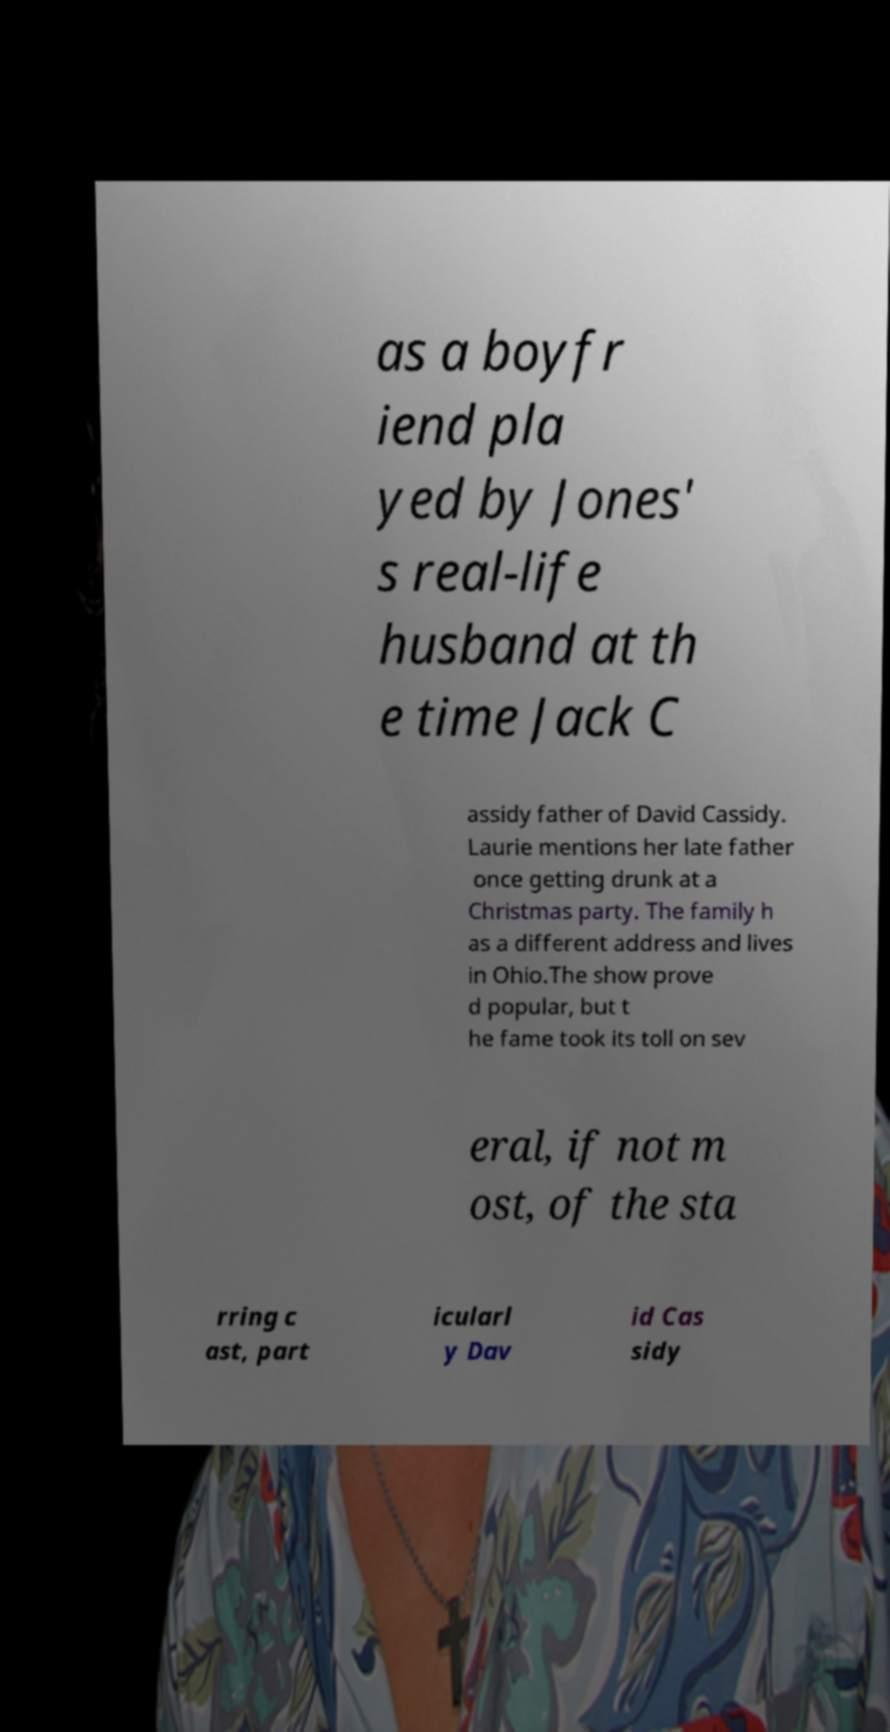For documentation purposes, I need the text within this image transcribed. Could you provide that? as a boyfr iend pla yed by Jones' s real-life husband at th e time Jack C assidy father of David Cassidy. Laurie mentions her late father once getting drunk at a Christmas party. The family h as a different address and lives in Ohio.The show prove d popular, but t he fame took its toll on sev eral, if not m ost, of the sta rring c ast, part icularl y Dav id Cas sidy 